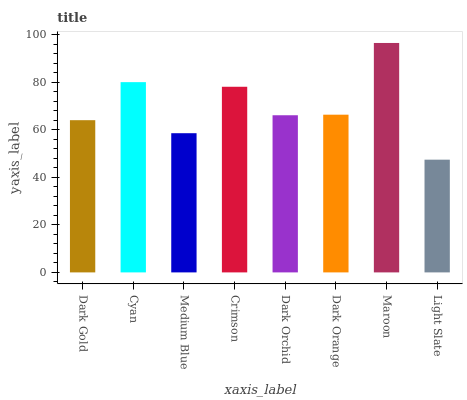Is Light Slate the minimum?
Answer yes or no. Yes. Is Maroon the maximum?
Answer yes or no. Yes. Is Cyan the minimum?
Answer yes or no. No. Is Cyan the maximum?
Answer yes or no. No. Is Cyan greater than Dark Gold?
Answer yes or no. Yes. Is Dark Gold less than Cyan?
Answer yes or no. Yes. Is Dark Gold greater than Cyan?
Answer yes or no. No. Is Cyan less than Dark Gold?
Answer yes or no. No. Is Dark Orange the high median?
Answer yes or no. Yes. Is Dark Orchid the low median?
Answer yes or no. Yes. Is Light Slate the high median?
Answer yes or no. No. Is Maroon the low median?
Answer yes or no. No. 